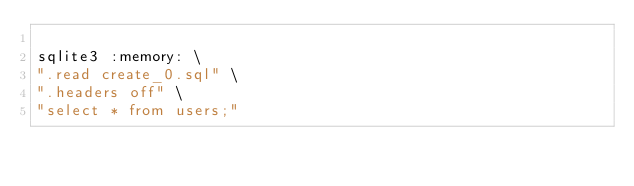<code> <loc_0><loc_0><loc_500><loc_500><_Bash_>
sqlite3 :memory: \
".read create_0.sql" \
".headers off" \
"select * from users;"

</code> 